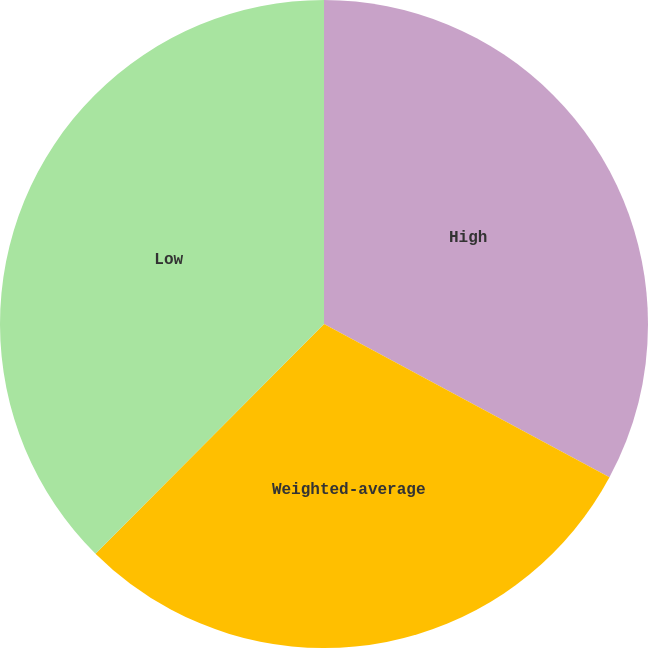Convert chart to OTSL. <chart><loc_0><loc_0><loc_500><loc_500><pie_chart><fcel>High<fcel>Weighted-average<fcel>Low<nl><fcel>32.84%<fcel>29.62%<fcel>37.54%<nl></chart> 